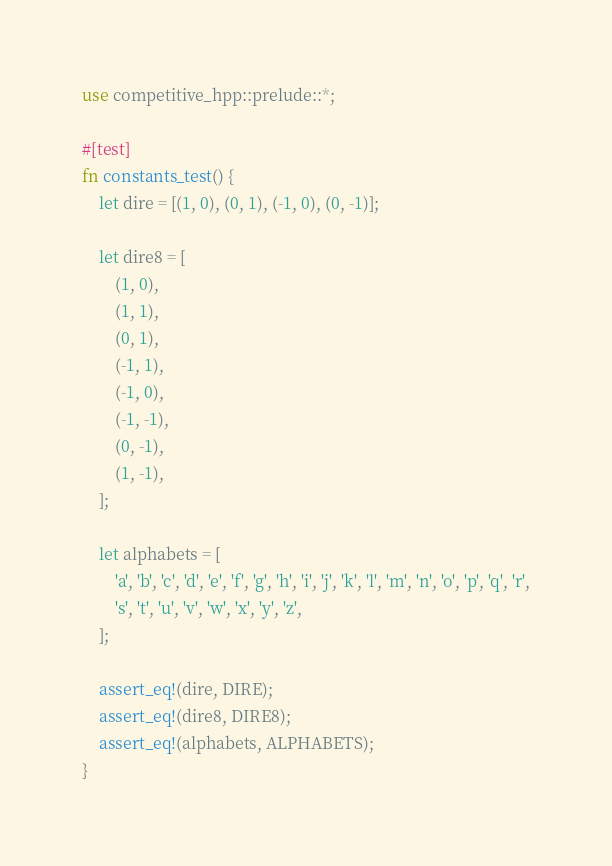Convert code to text. <code><loc_0><loc_0><loc_500><loc_500><_Rust_>use competitive_hpp::prelude::*;

#[test]
fn constants_test() {
    let dire = [(1, 0), (0, 1), (-1, 0), (0, -1)];

    let dire8 = [
        (1, 0),
        (1, 1),
        (0, 1),
        (-1, 1),
        (-1, 0),
        (-1, -1),
        (0, -1),
        (1, -1),
    ];

    let alphabets = [
        'a', 'b', 'c', 'd', 'e', 'f', 'g', 'h', 'i', 'j', 'k', 'l', 'm', 'n', 'o', 'p', 'q', 'r',
        's', 't', 'u', 'v', 'w', 'x', 'y', 'z',
    ];

    assert_eq!(dire, DIRE);
    assert_eq!(dire8, DIRE8);
    assert_eq!(alphabets, ALPHABETS);
}
</code> 